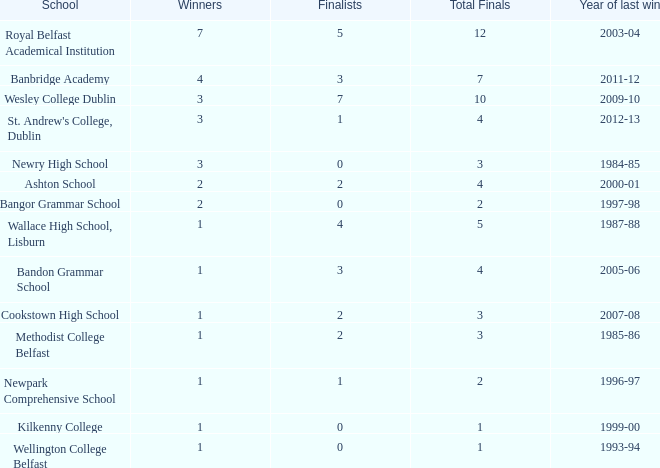How many overall finals were there when the most recent victory occurred in 2012-13? 4.0. Help me parse the entirety of this table. {'header': ['School', 'Winners', 'Finalists', 'Total Finals', 'Year of last win'], 'rows': [['Royal Belfast Academical Institution', '7', '5', '12', '2003-04'], ['Banbridge Academy', '4', '3', '7', '2011-12'], ['Wesley College Dublin', '3', '7', '10', '2009-10'], ["St. Andrew's College, Dublin", '3', '1', '4', '2012-13'], ['Newry High School', '3', '0', '3', '1984-85'], ['Ashton School', '2', '2', '4', '2000-01'], ['Bangor Grammar School', '2', '0', '2', '1997-98'], ['Wallace High School, Lisburn', '1', '4', '5', '1987-88'], ['Bandon Grammar School', '1', '3', '4', '2005-06'], ['Cookstown High School', '1', '2', '3', '2007-08'], ['Methodist College Belfast', '1', '2', '3', '1985-86'], ['Newpark Comprehensive School', '1', '1', '2', '1996-97'], ['Kilkenny College', '1', '0', '1', '1999-00'], ['Wellington College Belfast', '1', '0', '1', '1993-94']]} 